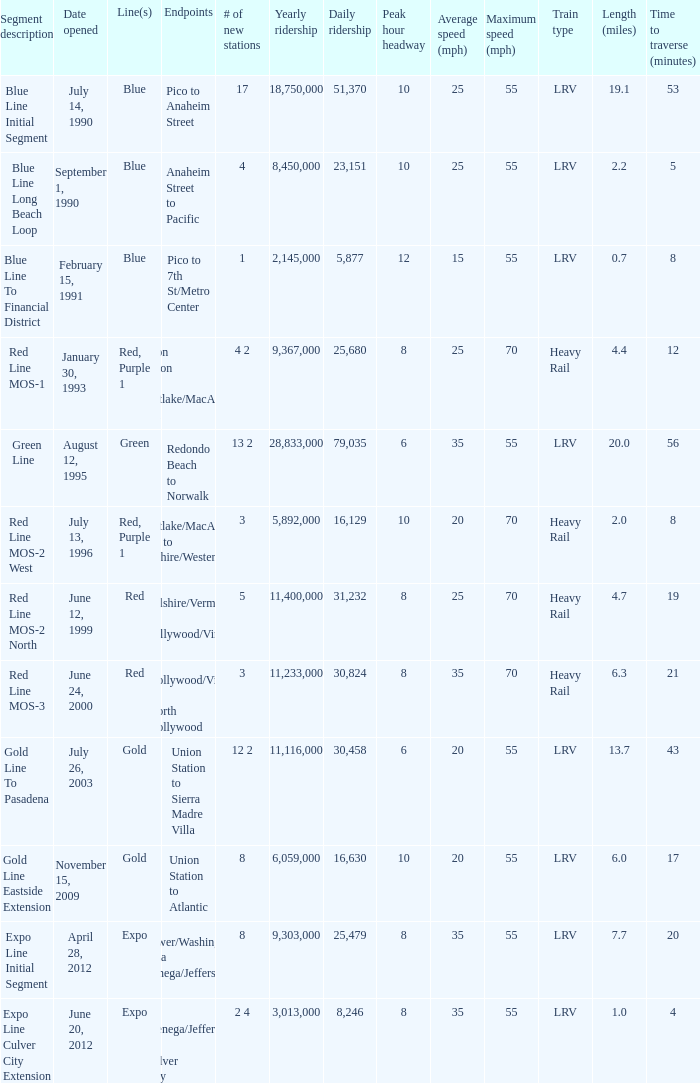What is the length  (miles) when pico to 7th st/metro center are the endpoints? 0.7. 